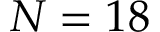Convert formula to latex. <formula><loc_0><loc_0><loc_500><loc_500>N = 1 8</formula> 